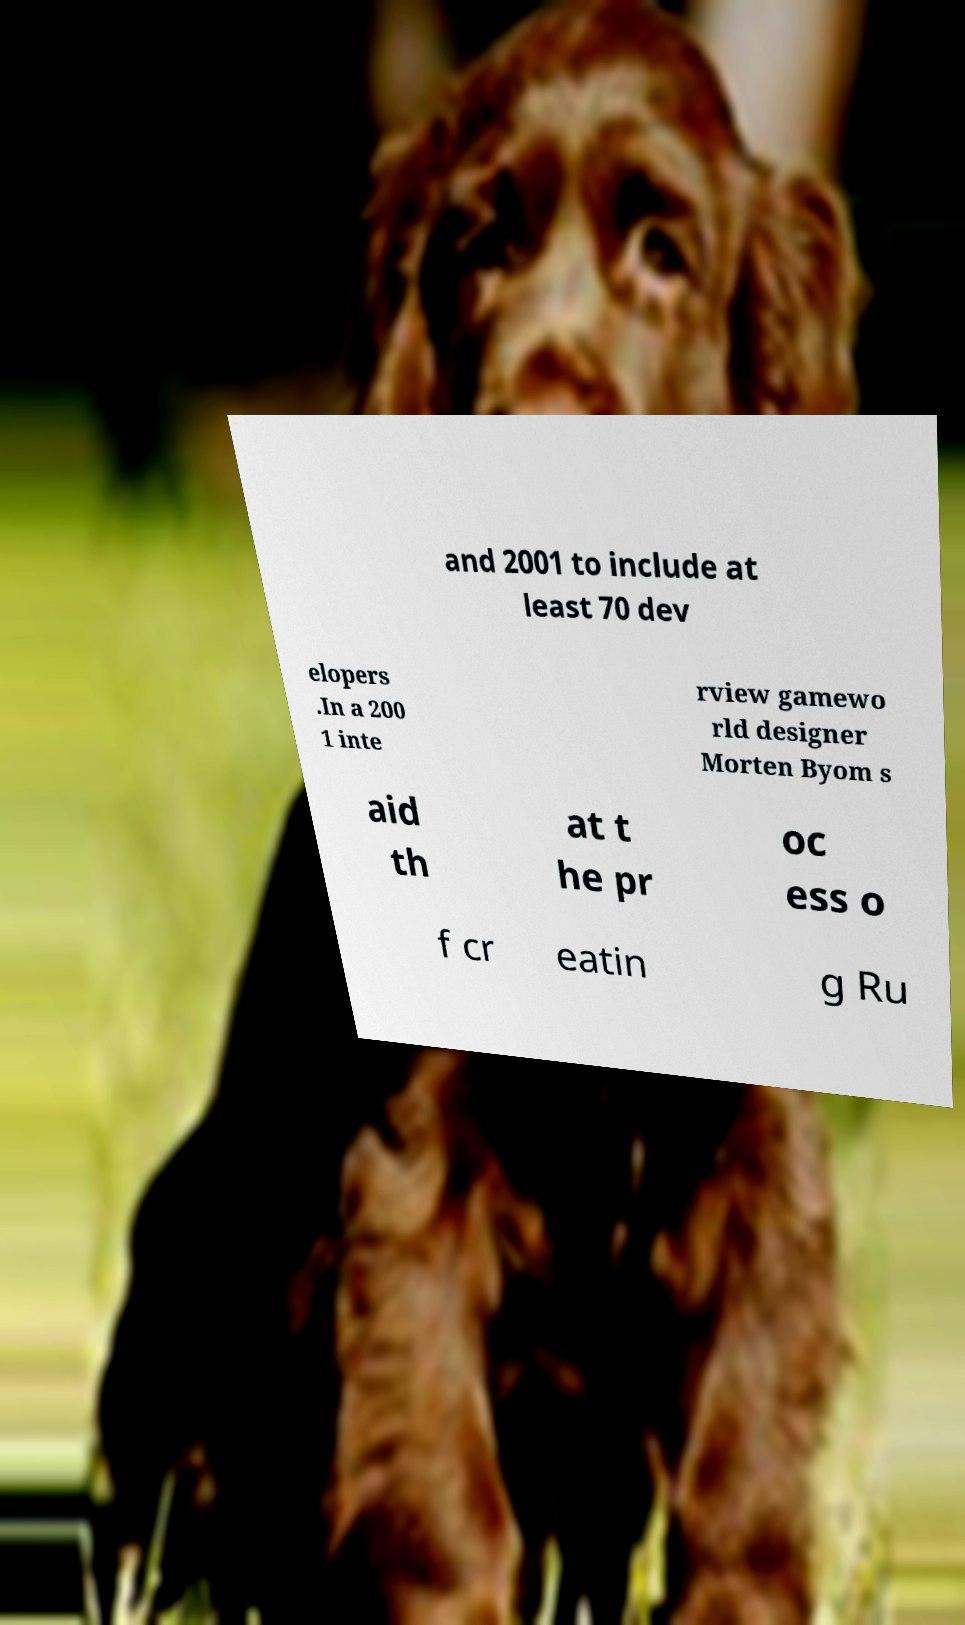What messages or text are displayed in this image? I need them in a readable, typed format. and 2001 to include at least 70 dev elopers .In a 200 1 inte rview gamewo rld designer Morten Byom s aid th at t he pr oc ess o f cr eatin g Ru 